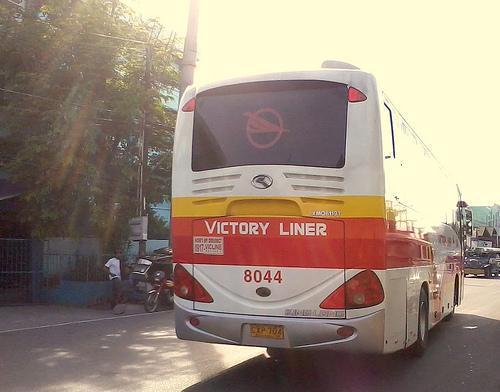How many buses are there?
Give a very brief answer. 1. 